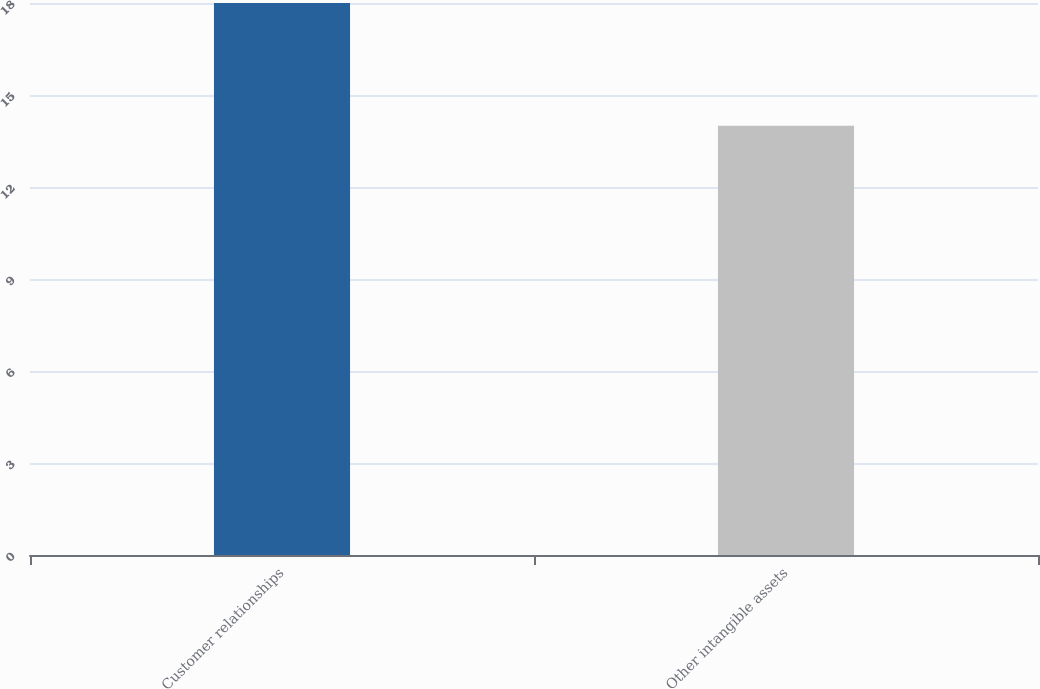Convert chart to OTSL. <chart><loc_0><loc_0><loc_500><loc_500><bar_chart><fcel>Customer relationships<fcel>Other intangible assets<nl><fcel>18<fcel>14<nl></chart> 